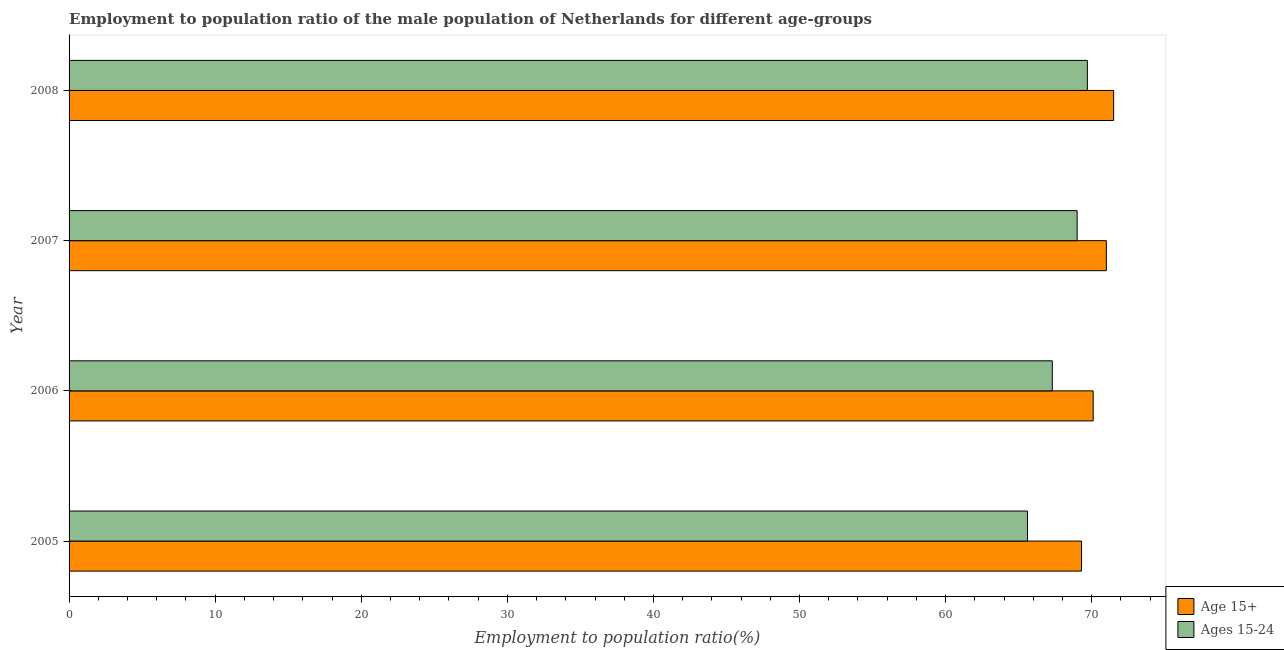How many different coloured bars are there?
Make the answer very short. 2. How many groups of bars are there?
Your answer should be very brief. 4. How many bars are there on the 2nd tick from the top?
Give a very brief answer. 2. How many bars are there on the 3rd tick from the bottom?
Provide a succinct answer. 2. What is the label of the 2nd group of bars from the top?
Your answer should be compact. 2007. What is the employment to population ratio(age 15+) in 2008?
Offer a terse response. 71.5. Across all years, what is the maximum employment to population ratio(age 15-24)?
Offer a very short reply. 69.7. Across all years, what is the minimum employment to population ratio(age 15-24)?
Your answer should be very brief. 65.6. In which year was the employment to population ratio(age 15-24) minimum?
Your response must be concise. 2005. What is the total employment to population ratio(age 15-24) in the graph?
Provide a succinct answer. 271.6. What is the difference between the employment to population ratio(age 15+) in 2006 and the employment to population ratio(age 15-24) in 2008?
Provide a succinct answer. 0.4. What is the average employment to population ratio(age 15+) per year?
Offer a terse response. 70.47. What is the ratio of the employment to population ratio(age 15+) in 2006 to that in 2008?
Offer a very short reply. 0.98. Is the employment to population ratio(age 15-24) in 2007 less than that in 2008?
Your answer should be compact. Yes. Is the difference between the employment to population ratio(age 15+) in 2006 and 2008 greater than the difference between the employment to population ratio(age 15-24) in 2006 and 2008?
Provide a short and direct response. Yes. What is the difference between the highest and the second highest employment to population ratio(age 15+)?
Provide a succinct answer. 0.5. What is the difference between the highest and the lowest employment to population ratio(age 15-24)?
Your answer should be very brief. 4.1. In how many years, is the employment to population ratio(age 15-24) greater than the average employment to population ratio(age 15-24) taken over all years?
Ensure brevity in your answer.  2. What does the 1st bar from the top in 2008 represents?
Give a very brief answer. Ages 15-24. What does the 1st bar from the bottom in 2005 represents?
Offer a very short reply. Age 15+. How many bars are there?
Ensure brevity in your answer.  8. What is the difference between two consecutive major ticks on the X-axis?
Ensure brevity in your answer.  10. How many legend labels are there?
Give a very brief answer. 2. How are the legend labels stacked?
Your response must be concise. Vertical. What is the title of the graph?
Your response must be concise. Employment to population ratio of the male population of Netherlands for different age-groups. What is the label or title of the X-axis?
Provide a short and direct response. Employment to population ratio(%). What is the label or title of the Y-axis?
Give a very brief answer. Year. What is the Employment to population ratio(%) in Age 15+ in 2005?
Provide a short and direct response. 69.3. What is the Employment to population ratio(%) of Ages 15-24 in 2005?
Provide a short and direct response. 65.6. What is the Employment to population ratio(%) of Age 15+ in 2006?
Provide a short and direct response. 70.1. What is the Employment to population ratio(%) in Ages 15-24 in 2006?
Provide a succinct answer. 67.3. What is the Employment to population ratio(%) of Age 15+ in 2008?
Provide a succinct answer. 71.5. What is the Employment to population ratio(%) in Ages 15-24 in 2008?
Make the answer very short. 69.7. Across all years, what is the maximum Employment to population ratio(%) of Age 15+?
Your response must be concise. 71.5. Across all years, what is the maximum Employment to population ratio(%) of Ages 15-24?
Provide a short and direct response. 69.7. Across all years, what is the minimum Employment to population ratio(%) of Age 15+?
Keep it short and to the point. 69.3. Across all years, what is the minimum Employment to population ratio(%) in Ages 15-24?
Give a very brief answer. 65.6. What is the total Employment to population ratio(%) in Age 15+ in the graph?
Keep it short and to the point. 281.9. What is the total Employment to population ratio(%) in Ages 15-24 in the graph?
Offer a terse response. 271.6. What is the difference between the Employment to population ratio(%) of Ages 15-24 in 2005 and that in 2006?
Your answer should be very brief. -1.7. What is the difference between the Employment to population ratio(%) in Age 15+ in 2005 and that in 2007?
Keep it short and to the point. -1.7. What is the difference between the Employment to population ratio(%) in Age 15+ in 2005 and that in 2008?
Provide a short and direct response. -2.2. What is the difference between the Employment to population ratio(%) of Ages 15-24 in 2005 and that in 2008?
Provide a short and direct response. -4.1. What is the difference between the Employment to population ratio(%) in Age 15+ in 2006 and that in 2007?
Provide a short and direct response. -0.9. What is the difference between the Employment to population ratio(%) in Ages 15-24 in 2006 and that in 2007?
Ensure brevity in your answer.  -1.7. What is the difference between the Employment to population ratio(%) in Age 15+ in 2006 and that in 2008?
Offer a very short reply. -1.4. What is the difference between the Employment to population ratio(%) in Ages 15-24 in 2007 and that in 2008?
Your answer should be very brief. -0.7. What is the difference between the Employment to population ratio(%) in Age 15+ in 2005 and the Employment to population ratio(%) in Ages 15-24 in 2006?
Make the answer very short. 2. What is the difference between the Employment to population ratio(%) of Age 15+ in 2005 and the Employment to population ratio(%) of Ages 15-24 in 2007?
Your answer should be compact. 0.3. What is the average Employment to population ratio(%) in Age 15+ per year?
Your answer should be very brief. 70.47. What is the average Employment to population ratio(%) of Ages 15-24 per year?
Make the answer very short. 67.9. In the year 2005, what is the difference between the Employment to population ratio(%) of Age 15+ and Employment to population ratio(%) of Ages 15-24?
Ensure brevity in your answer.  3.7. In the year 2006, what is the difference between the Employment to population ratio(%) in Age 15+ and Employment to population ratio(%) in Ages 15-24?
Your answer should be very brief. 2.8. In the year 2008, what is the difference between the Employment to population ratio(%) in Age 15+ and Employment to population ratio(%) in Ages 15-24?
Provide a short and direct response. 1.8. What is the ratio of the Employment to population ratio(%) in Ages 15-24 in 2005 to that in 2006?
Provide a short and direct response. 0.97. What is the ratio of the Employment to population ratio(%) of Age 15+ in 2005 to that in 2007?
Provide a short and direct response. 0.98. What is the ratio of the Employment to population ratio(%) of Ages 15-24 in 2005 to that in 2007?
Your answer should be very brief. 0.95. What is the ratio of the Employment to population ratio(%) in Age 15+ in 2005 to that in 2008?
Keep it short and to the point. 0.97. What is the ratio of the Employment to population ratio(%) in Age 15+ in 2006 to that in 2007?
Give a very brief answer. 0.99. What is the ratio of the Employment to population ratio(%) in Ages 15-24 in 2006 to that in 2007?
Ensure brevity in your answer.  0.98. What is the ratio of the Employment to population ratio(%) in Age 15+ in 2006 to that in 2008?
Your answer should be very brief. 0.98. What is the ratio of the Employment to population ratio(%) of Ages 15-24 in 2006 to that in 2008?
Provide a succinct answer. 0.97. What is the ratio of the Employment to population ratio(%) in Age 15+ in 2007 to that in 2008?
Your answer should be very brief. 0.99. What is the ratio of the Employment to population ratio(%) in Ages 15-24 in 2007 to that in 2008?
Provide a succinct answer. 0.99. What is the difference between the highest and the second highest Employment to population ratio(%) in Age 15+?
Offer a terse response. 0.5. What is the difference between the highest and the second highest Employment to population ratio(%) of Ages 15-24?
Offer a very short reply. 0.7. 